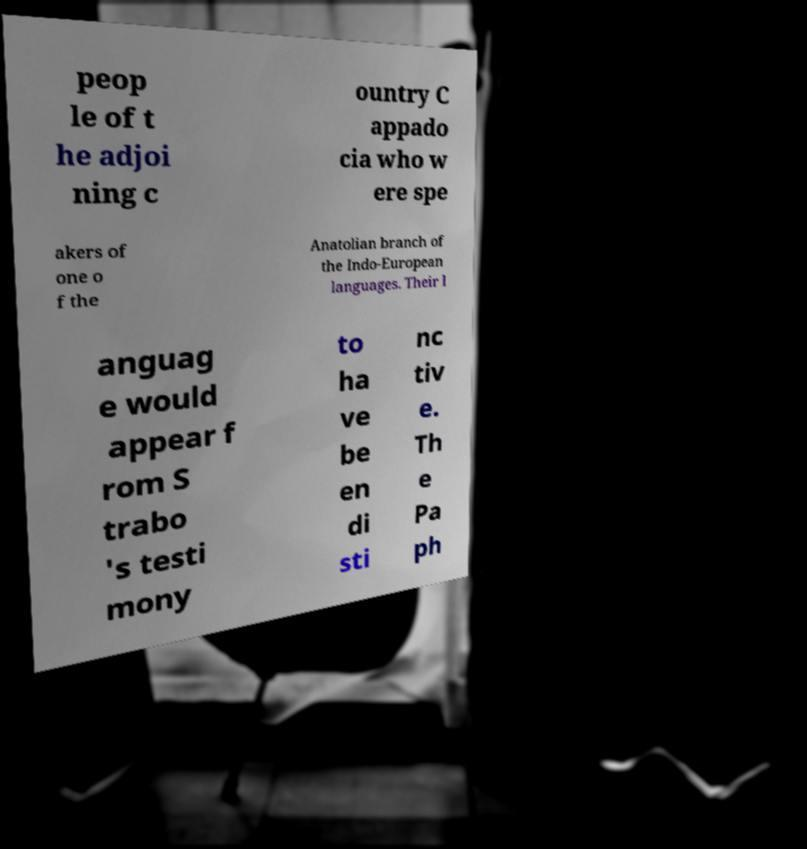Can you accurately transcribe the text from the provided image for me? peop le of t he adjoi ning c ountry C appado cia who w ere spe akers of one o f the Anatolian branch of the Indo-European languages. Their l anguag e would appear f rom S trabo 's testi mony to ha ve be en di sti nc tiv e. Th e Pa ph 